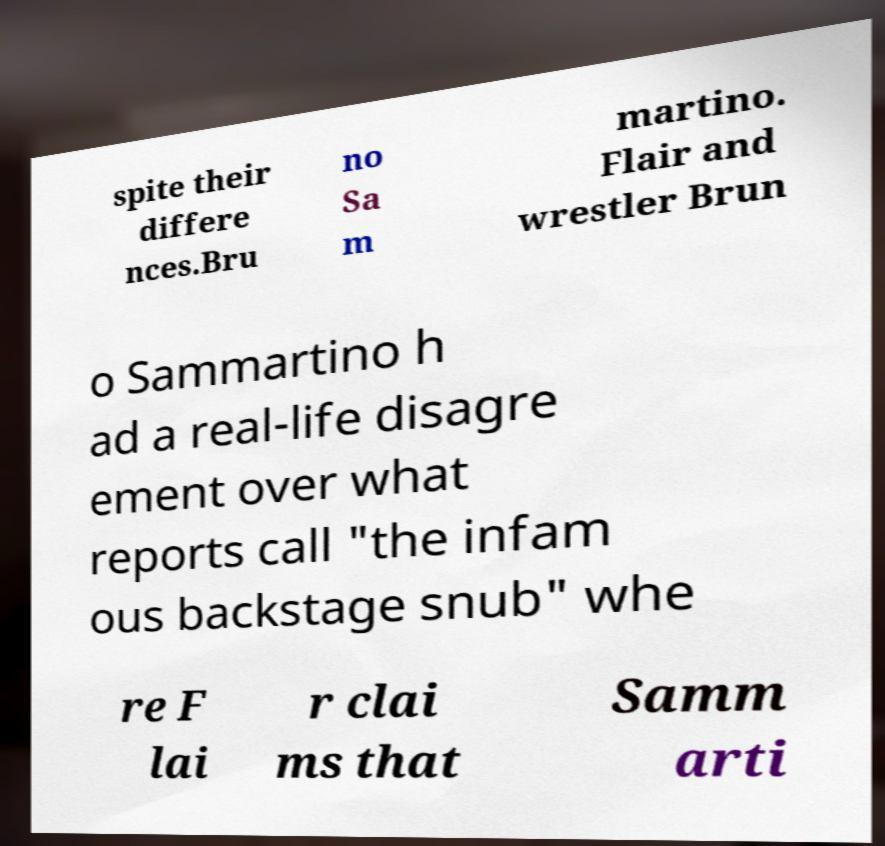I need the written content from this picture converted into text. Can you do that? spite their differe nces.Bru no Sa m martino. Flair and wrestler Brun o Sammartino h ad a real-life disagre ement over what reports call "the infam ous backstage snub" whe re F lai r clai ms that Samm arti 